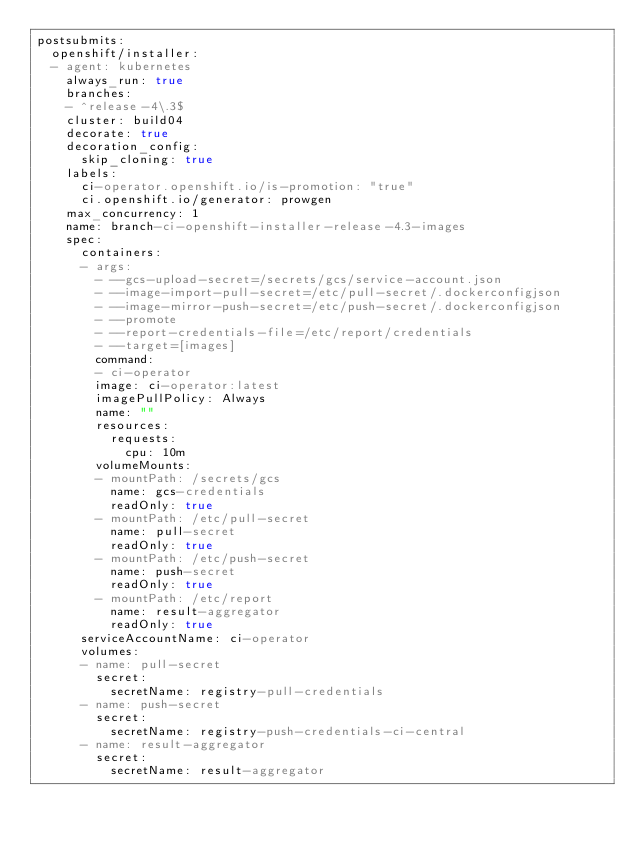Convert code to text. <code><loc_0><loc_0><loc_500><loc_500><_YAML_>postsubmits:
  openshift/installer:
  - agent: kubernetes
    always_run: true
    branches:
    - ^release-4\.3$
    cluster: build04
    decorate: true
    decoration_config:
      skip_cloning: true
    labels:
      ci-operator.openshift.io/is-promotion: "true"
      ci.openshift.io/generator: prowgen
    max_concurrency: 1
    name: branch-ci-openshift-installer-release-4.3-images
    spec:
      containers:
      - args:
        - --gcs-upload-secret=/secrets/gcs/service-account.json
        - --image-import-pull-secret=/etc/pull-secret/.dockerconfigjson
        - --image-mirror-push-secret=/etc/push-secret/.dockerconfigjson
        - --promote
        - --report-credentials-file=/etc/report/credentials
        - --target=[images]
        command:
        - ci-operator
        image: ci-operator:latest
        imagePullPolicy: Always
        name: ""
        resources:
          requests:
            cpu: 10m
        volumeMounts:
        - mountPath: /secrets/gcs
          name: gcs-credentials
          readOnly: true
        - mountPath: /etc/pull-secret
          name: pull-secret
          readOnly: true
        - mountPath: /etc/push-secret
          name: push-secret
          readOnly: true
        - mountPath: /etc/report
          name: result-aggregator
          readOnly: true
      serviceAccountName: ci-operator
      volumes:
      - name: pull-secret
        secret:
          secretName: registry-pull-credentials
      - name: push-secret
        secret:
          secretName: registry-push-credentials-ci-central
      - name: result-aggregator
        secret:
          secretName: result-aggregator
</code> 